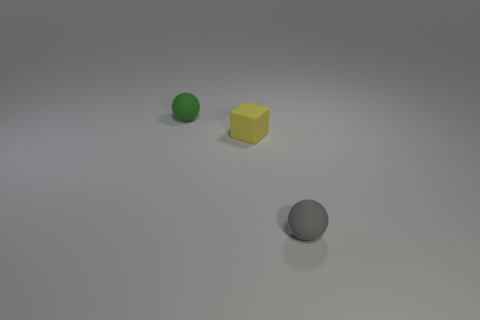Add 2 green rubber objects. How many objects exist? 5 Subtract all balls. How many objects are left? 1 Add 2 tiny blue blocks. How many tiny blue blocks exist? 2 Subtract 0 brown cubes. How many objects are left? 3 Subtract all gray things. Subtract all tiny matte cubes. How many objects are left? 1 Add 1 tiny green rubber objects. How many tiny green rubber objects are left? 2 